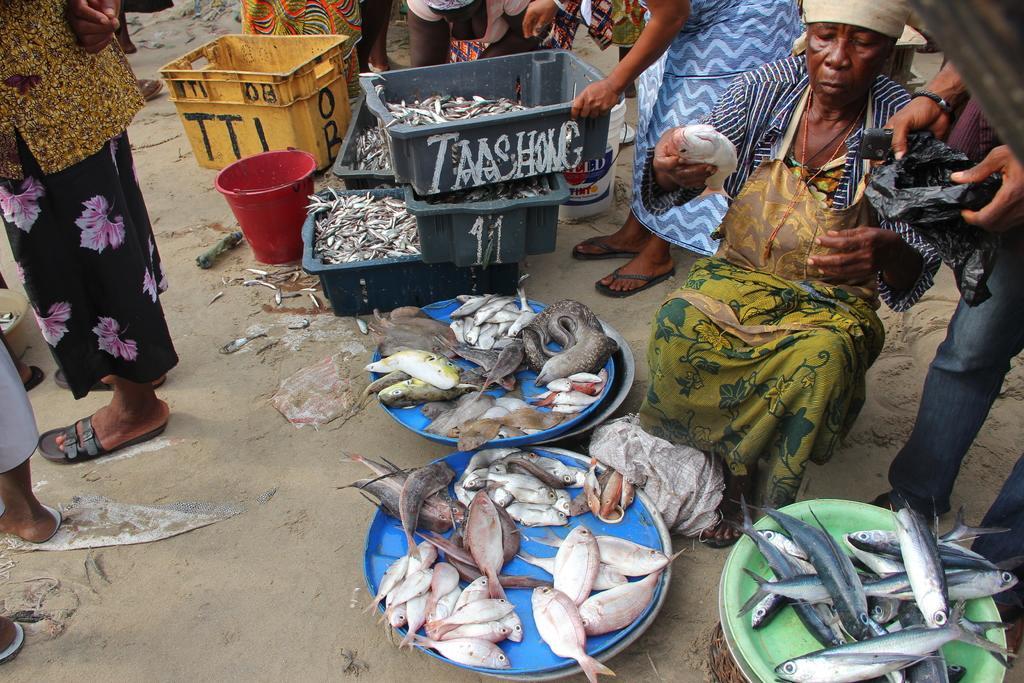In one or two sentences, can you explain what this image depicts? In this picture we can see a few fishes in the boxes and some fishes on the colorful objects. We can see a few people holding objects in their hands. There are the legs of people with footwear, buckets and some objects on the ground. 